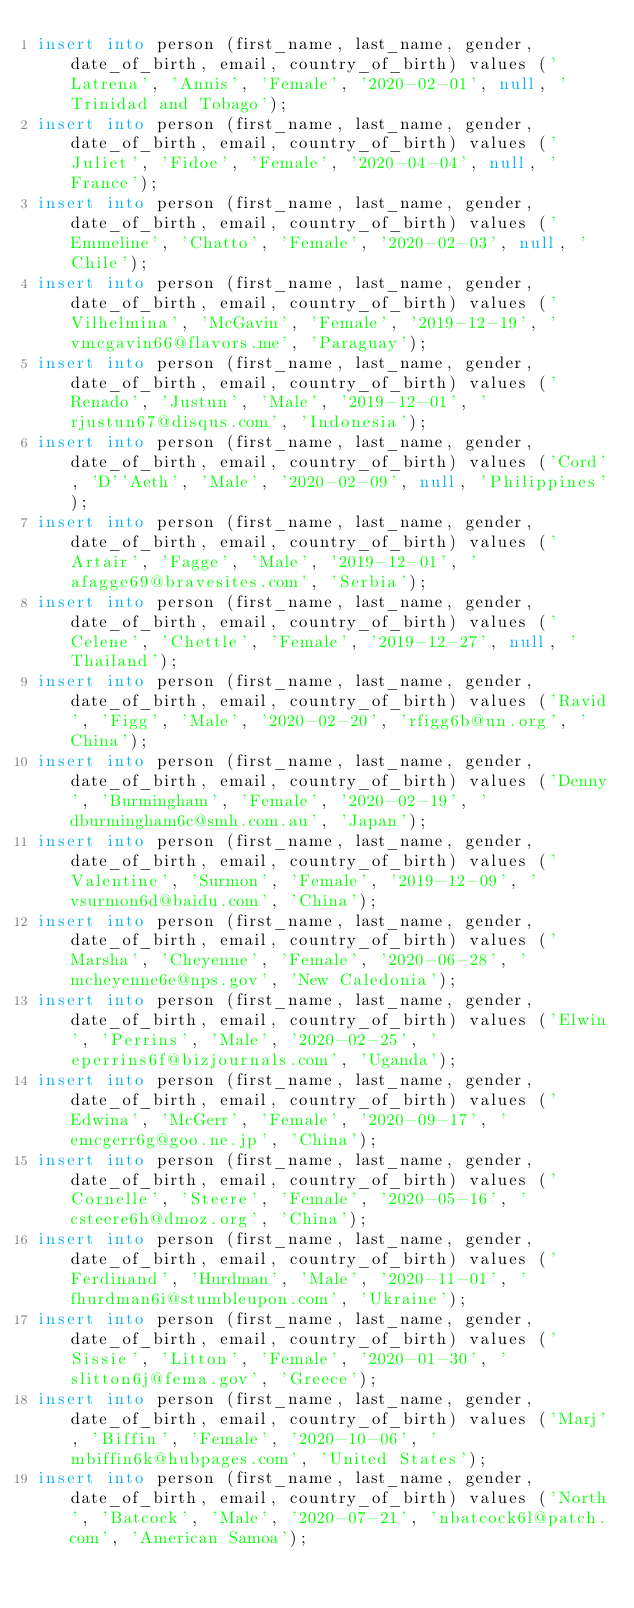<code> <loc_0><loc_0><loc_500><loc_500><_SQL_>insert into person (first_name, last_name, gender, date_of_birth, email, country_of_birth) values ('Latrena', 'Annis', 'Female', '2020-02-01', null, 'Trinidad and Tobago');
insert into person (first_name, last_name, gender, date_of_birth, email, country_of_birth) values ('Juliet', 'Fidoe', 'Female', '2020-04-04', null, 'France');
insert into person (first_name, last_name, gender, date_of_birth, email, country_of_birth) values ('Emmeline', 'Chatto', 'Female', '2020-02-03', null, 'Chile');
insert into person (first_name, last_name, gender, date_of_birth, email, country_of_birth) values ('Vilhelmina', 'McGavin', 'Female', '2019-12-19', 'vmcgavin66@flavors.me', 'Paraguay');
insert into person (first_name, last_name, gender, date_of_birth, email, country_of_birth) values ('Renado', 'Justun', 'Male', '2019-12-01', 'rjustun67@disqus.com', 'Indonesia');
insert into person (first_name, last_name, gender, date_of_birth, email, country_of_birth) values ('Cord', 'D''Aeth', 'Male', '2020-02-09', null, 'Philippines');
insert into person (first_name, last_name, gender, date_of_birth, email, country_of_birth) values ('Artair', 'Fagge', 'Male', '2019-12-01', 'afagge69@bravesites.com', 'Serbia');
insert into person (first_name, last_name, gender, date_of_birth, email, country_of_birth) values ('Celene', 'Chettle', 'Female', '2019-12-27', null, 'Thailand');
insert into person (first_name, last_name, gender, date_of_birth, email, country_of_birth) values ('Ravid', 'Figg', 'Male', '2020-02-20', 'rfigg6b@un.org', 'China');
insert into person (first_name, last_name, gender, date_of_birth, email, country_of_birth) values ('Denny', 'Burmingham', 'Female', '2020-02-19', 'dburmingham6c@smh.com.au', 'Japan');
insert into person (first_name, last_name, gender, date_of_birth, email, country_of_birth) values ('Valentine', 'Surmon', 'Female', '2019-12-09', 'vsurmon6d@baidu.com', 'China');
insert into person (first_name, last_name, gender, date_of_birth, email, country_of_birth) values ('Marsha', 'Cheyenne', 'Female', '2020-06-28', 'mcheyenne6e@nps.gov', 'New Caledonia');
insert into person (first_name, last_name, gender, date_of_birth, email, country_of_birth) values ('Elwin', 'Perrins', 'Male', '2020-02-25', 'eperrins6f@bizjournals.com', 'Uganda');
insert into person (first_name, last_name, gender, date_of_birth, email, country_of_birth) values ('Edwina', 'McGerr', 'Female', '2020-09-17', 'emcgerr6g@goo.ne.jp', 'China');
insert into person (first_name, last_name, gender, date_of_birth, email, country_of_birth) values ('Cornelle', 'Steere', 'Female', '2020-05-16', 'csteere6h@dmoz.org', 'China');
insert into person (first_name, last_name, gender, date_of_birth, email, country_of_birth) values ('Ferdinand', 'Hurdman', 'Male', '2020-11-01', 'fhurdman6i@stumbleupon.com', 'Ukraine');
insert into person (first_name, last_name, gender, date_of_birth, email, country_of_birth) values ('Sissie', 'Litton', 'Female', '2020-01-30', 'slitton6j@fema.gov', 'Greece');
insert into person (first_name, last_name, gender, date_of_birth, email, country_of_birth) values ('Marj', 'Biffin', 'Female', '2020-10-06', 'mbiffin6k@hubpages.com', 'United States');
insert into person (first_name, last_name, gender, date_of_birth, email, country_of_birth) values ('North', 'Batcock', 'Male', '2020-07-21', 'nbatcock6l@patch.com', 'American Samoa');</code> 